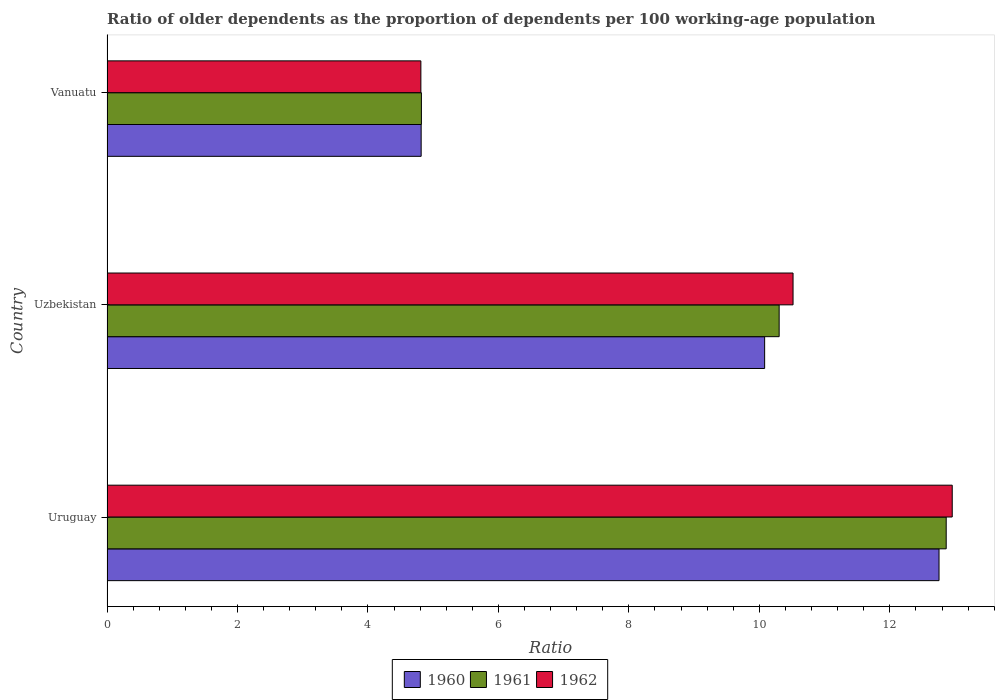How many different coloured bars are there?
Offer a terse response. 3. Are the number of bars on each tick of the Y-axis equal?
Offer a very short reply. Yes. How many bars are there on the 1st tick from the bottom?
Your response must be concise. 3. What is the label of the 2nd group of bars from the top?
Offer a very short reply. Uzbekistan. In how many cases, is the number of bars for a given country not equal to the number of legend labels?
Keep it short and to the point. 0. What is the age dependency ratio(old) in 1962 in Uruguay?
Keep it short and to the point. 12.96. Across all countries, what is the maximum age dependency ratio(old) in 1962?
Offer a very short reply. 12.96. Across all countries, what is the minimum age dependency ratio(old) in 1960?
Your answer should be compact. 4.82. In which country was the age dependency ratio(old) in 1961 maximum?
Keep it short and to the point. Uruguay. In which country was the age dependency ratio(old) in 1961 minimum?
Provide a short and direct response. Vanuatu. What is the total age dependency ratio(old) in 1962 in the graph?
Give a very brief answer. 28.29. What is the difference between the age dependency ratio(old) in 1962 in Uzbekistan and that in Vanuatu?
Ensure brevity in your answer.  5.71. What is the difference between the age dependency ratio(old) in 1961 in Uzbekistan and the age dependency ratio(old) in 1962 in Uruguay?
Your answer should be compact. -2.65. What is the average age dependency ratio(old) in 1962 per country?
Provide a succinct answer. 9.43. What is the difference between the age dependency ratio(old) in 1962 and age dependency ratio(old) in 1961 in Uruguay?
Offer a terse response. 0.09. In how many countries, is the age dependency ratio(old) in 1960 greater than 12 ?
Provide a succinct answer. 1. What is the ratio of the age dependency ratio(old) in 1961 in Uruguay to that in Uzbekistan?
Keep it short and to the point. 1.25. Is the age dependency ratio(old) in 1961 in Uruguay less than that in Uzbekistan?
Make the answer very short. No. What is the difference between the highest and the second highest age dependency ratio(old) in 1962?
Your answer should be very brief. 2.44. What is the difference between the highest and the lowest age dependency ratio(old) in 1962?
Offer a very short reply. 8.15. In how many countries, is the age dependency ratio(old) in 1961 greater than the average age dependency ratio(old) in 1961 taken over all countries?
Your answer should be compact. 2. What does the 3rd bar from the bottom in Vanuatu represents?
Your response must be concise. 1962. Are all the bars in the graph horizontal?
Provide a short and direct response. Yes. How many countries are there in the graph?
Provide a short and direct response. 3. Are the values on the major ticks of X-axis written in scientific E-notation?
Offer a terse response. No. Does the graph contain grids?
Your answer should be very brief. No. How many legend labels are there?
Offer a terse response. 3. What is the title of the graph?
Provide a short and direct response. Ratio of older dependents as the proportion of dependents per 100 working-age population. What is the label or title of the X-axis?
Provide a short and direct response. Ratio. What is the Ratio of 1960 in Uruguay?
Provide a short and direct response. 12.75. What is the Ratio of 1961 in Uruguay?
Provide a short and direct response. 12.86. What is the Ratio in 1962 in Uruguay?
Your response must be concise. 12.96. What is the Ratio of 1960 in Uzbekistan?
Your answer should be compact. 10.08. What is the Ratio in 1961 in Uzbekistan?
Your response must be concise. 10.3. What is the Ratio of 1962 in Uzbekistan?
Your answer should be compact. 10.52. What is the Ratio in 1960 in Vanuatu?
Provide a succinct answer. 4.82. What is the Ratio of 1961 in Vanuatu?
Provide a succinct answer. 4.82. What is the Ratio of 1962 in Vanuatu?
Your answer should be very brief. 4.81. Across all countries, what is the maximum Ratio in 1960?
Make the answer very short. 12.75. Across all countries, what is the maximum Ratio of 1961?
Keep it short and to the point. 12.86. Across all countries, what is the maximum Ratio in 1962?
Give a very brief answer. 12.96. Across all countries, what is the minimum Ratio of 1960?
Your answer should be very brief. 4.82. Across all countries, what is the minimum Ratio of 1961?
Offer a terse response. 4.82. Across all countries, what is the minimum Ratio of 1962?
Your response must be concise. 4.81. What is the total Ratio in 1960 in the graph?
Provide a succinct answer. 27.65. What is the total Ratio in 1961 in the graph?
Your response must be concise. 27.99. What is the total Ratio of 1962 in the graph?
Your answer should be very brief. 28.29. What is the difference between the Ratio of 1960 in Uruguay and that in Uzbekistan?
Offer a terse response. 2.67. What is the difference between the Ratio in 1961 in Uruguay and that in Uzbekistan?
Make the answer very short. 2.56. What is the difference between the Ratio of 1962 in Uruguay and that in Uzbekistan?
Ensure brevity in your answer.  2.44. What is the difference between the Ratio in 1960 in Uruguay and that in Vanuatu?
Keep it short and to the point. 7.94. What is the difference between the Ratio of 1961 in Uruguay and that in Vanuatu?
Your answer should be very brief. 8.04. What is the difference between the Ratio in 1962 in Uruguay and that in Vanuatu?
Provide a succinct answer. 8.15. What is the difference between the Ratio in 1960 in Uzbekistan and that in Vanuatu?
Your answer should be compact. 5.27. What is the difference between the Ratio in 1961 in Uzbekistan and that in Vanuatu?
Make the answer very short. 5.48. What is the difference between the Ratio in 1962 in Uzbekistan and that in Vanuatu?
Your answer should be compact. 5.71. What is the difference between the Ratio in 1960 in Uruguay and the Ratio in 1961 in Uzbekistan?
Your answer should be compact. 2.45. What is the difference between the Ratio in 1960 in Uruguay and the Ratio in 1962 in Uzbekistan?
Give a very brief answer. 2.24. What is the difference between the Ratio of 1961 in Uruguay and the Ratio of 1962 in Uzbekistan?
Ensure brevity in your answer.  2.35. What is the difference between the Ratio in 1960 in Uruguay and the Ratio in 1961 in Vanuatu?
Keep it short and to the point. 7.93. What is the difference between the Ratio in 1960 in Uruguay and the Ratio in 1962 in Vanuatu?
Provide a short and direct response. 7.94. What is the difference between the Ratio in 1961 in Uruguay and the Ratio in 1962 in Vanuatu?
Provide a short and direct response. 8.05. What is the difference between the Ratio in 1960 in Uzbekistan and the Ratio in 1961 in Vanuatu?
Ensure brevity in your answer.  5.26. What is the difference between the Ratio of 1960 in Uzbekistan and the Ratio of 1962 in Vanuatu?
Your response must be concise. 5.27. What is the difference between the Ratio of 1961 in Uzbekistan and the Ratio of 1962 in Vanuatu?
Provide a succinct answer. 5.49. What is the average Ratio of 1960 per country?
Keep it short and to the point. 9.22. What is the average Ratio in 1961 per country?
Give a very brief answer. 9.33. What is the average Ratio of 1962 per country?
Offer a very short reply. 9.43. What is the difference between the Ratio in 1960 and Ratio in 1961 in Uruguay?
Your answer should be compact. -0.11. What is the difference between the Ratio of 1960 and Ratio of 1962 in Uruguay?
Provide a short and direct response. -0.2. What is the difference between the Ratio of 1961 and Ratio of 1962 in Uruguay?
Provide a succinct answer. -0.09. What is the difference between the Ratio of 1960 and Ratio of 1961 in Uzbekistan?
Ensure brevity in your answer.  -0.22. What is the difference between the Ratio in 1960 and Ratio in 1962 in Uzbekistan?
Keep it short and to the point. -0.44. What is the difference between the Ratio of 1961 and Ratio of 1962 in Uzbekistan?
Give a very brief answer. -0.21. What is the difference between the Ratio in 1960 and Ratio in 1961 in Vanuatu?
Your response must be concise. -0. What is the difference between the Ratio of 1960 and Ratio of 1962 in Vanuatu?
Offer a terse response. 0. What is the difference between the Ratio of 1961 and Ratio of 1962 in Vanuatu?
Your answer should be compact. 0.01. What is the ratio of the Ratio in 1960 in Uruguay to that in Uzbekistan?
Keep it short and to the point. 1.27. What is the ratio of the Ratio in 1961 in Uruguay to that in Uzbekistan?
Your answer should be compact. 1.25. What is the ratio of the Ratio of 1962 in Uruguay to that in Uzbekistan?
Offer a very short reply. 1.23. What is the ratio of the Ratio of 1960 in Uruguay to that in Vanuatu?
Your answer should be very brief. 2.65. What is the ratio of the Ratio of 1961 in Uruguay to that in Vanuatu?
Your answer should be compact. 2.67. What is the ratio of the Ratio in 1962 in Uruguay to that in Vanuatu?
Give a very brief answer. 2.69. What is the ratio of the Ratio of 1960 in Uzbekistan to that in Vanuatu?
Provide a short and direct response. 2.09. What is the ratio of the Ratio in 1961 in Uzbekistan to that in Vanuatu?
Your answer should be compact. 2.14. What is the ratio of the Ratio of 1962 in Uzbekistan to that in Vanuatu?
Your response must be concise. 2.19. What is the difference between the highest and the second highest Ratio of 1960?
Offer a very short reply. 2.67. What is the difference between the highest and the second highest Ratio in 1961?
Offer a very short reply. 2.56. What is the difference between the highest and the second highest Ratio in 1962?
Provide a succinct answer. 2.44. What is the difference between the highest and the lowest Ratio of 1960?
Your answer should be compact. 7.94. What is the difference between the highest and the lowest Ratio of 1961?
Give a very brief answer. 8.04. What is the difference between the highest and the lowest Ratio of 1962?
Your answer should be very brief. 8.15. 